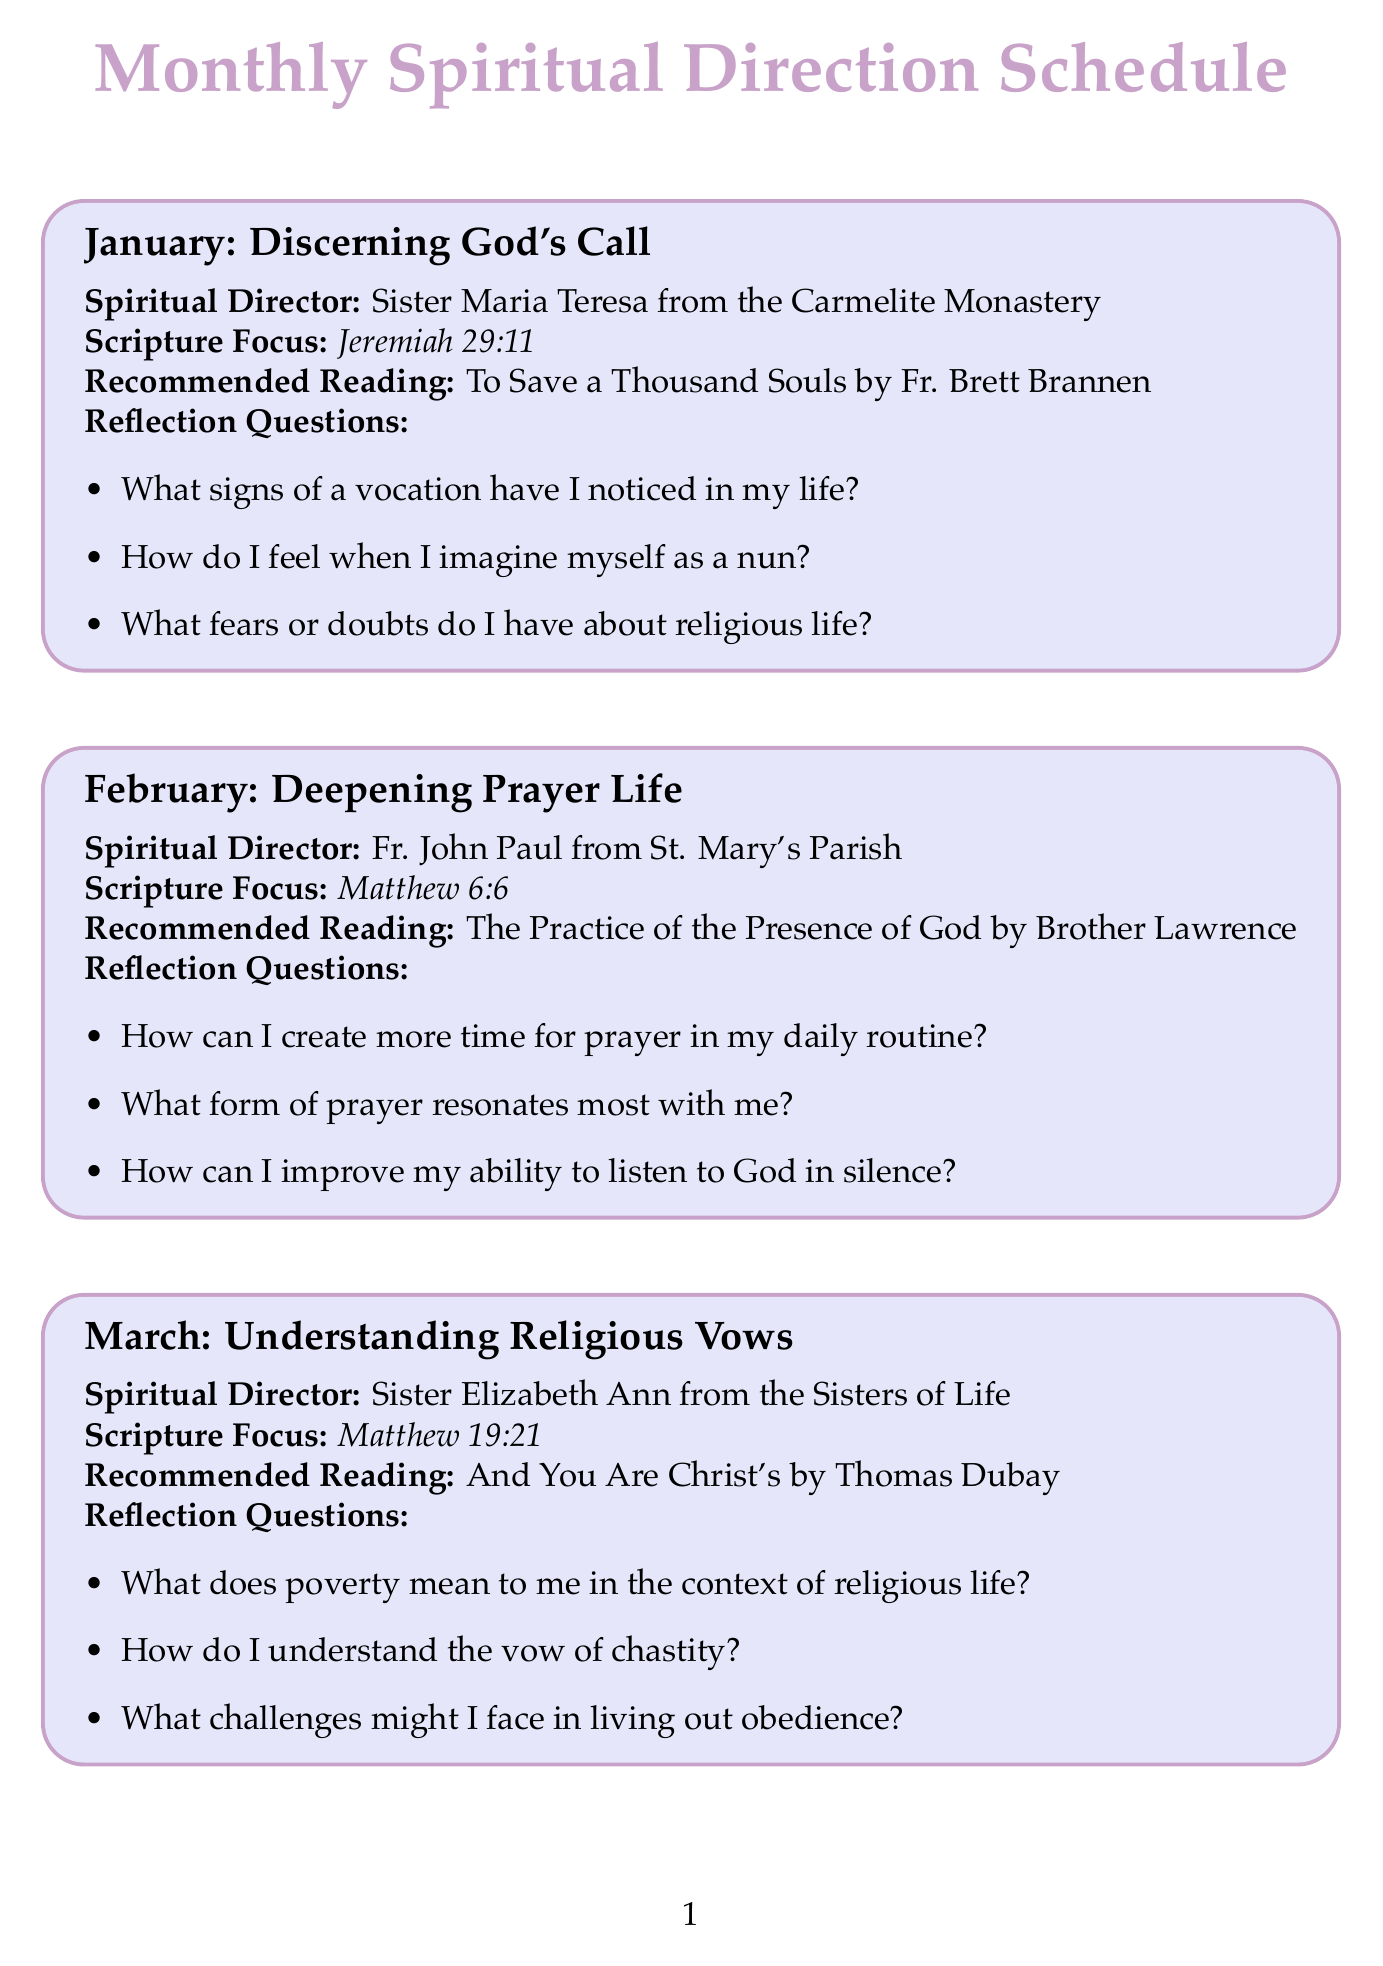What is the theme for March? The theme for March is "Understanding Religious Vows," as listed in the document.
Answer: Understanding Religious Vows Who is the suggested director for April? The document specifies Fr. Michael from the Franciscan Friars of the Renewal as the director for April.
Answer: Fr. Michael from the Franciscan Friars of the Renewal What scripture focus is listed for February? According to the document, the scripture focus for February is Matthew 6:6.
Answer: Matthew 6:6 How many reflection questions are suggested for the January session? The document states that there are three reflection questions suggested for January.
Answer: 3 What is the recommended reading for May? The document indicates that the recommended reading for May is "True Devotion to Mary by St. Louis de Montfort."
Answer: True Devotion to Mary by St. Louis de Montfort Which month focuses on Marian Devotion? The document shows that the month focusing on Marian Devotion is May.
Answer: May What is a reflection question for June? One of the reflection questions for June, as noted in the document, is "How has Eucharistic Adoration impacted my discernment?"
Answer: How has Eucharistic Adoration impacted my discernment? What is the central theme of the monthly sessions? The document indicates that the central theme is to guide individuals in their spiritual direction and vocation discernment process.
Answer: Vocation discernment process 